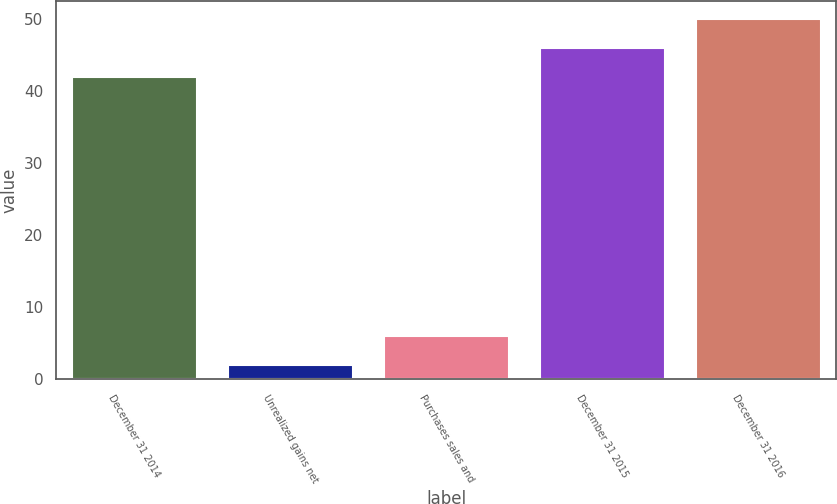<chart> <loc_0><loc_0><loc_500><loc_500><bar_chart><fcel>December 31 2014<fcel>Unrealized gains net<fcel>Purchases sales and<fcel>December 31 2015<fcel>December 31 2016<nl><fcel>42<fcel>2<fcel>6<fcel>46<fcel>50<nl></chart> 